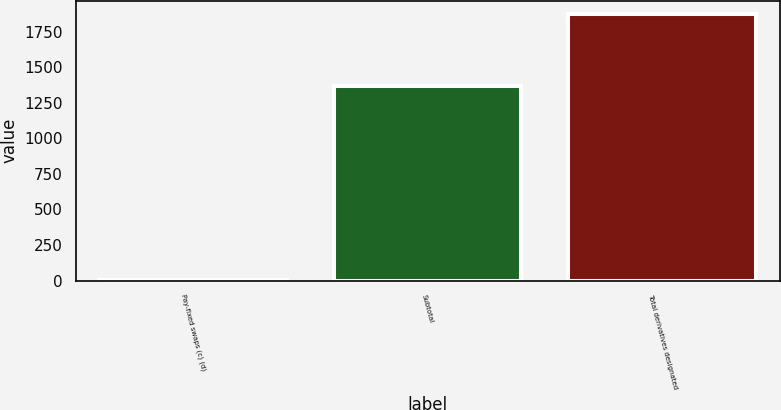Convert chart to OTSL. <chart><loc_0><loc_0><loc_500><loc_500><bar_chart><fcel>Pay-fixed swaps (c) (d)<fcel>Subtotal<fcel>Total derivatives designated<nl><fcel>2<fcel>1367<fcel>1872<nl></chart> 